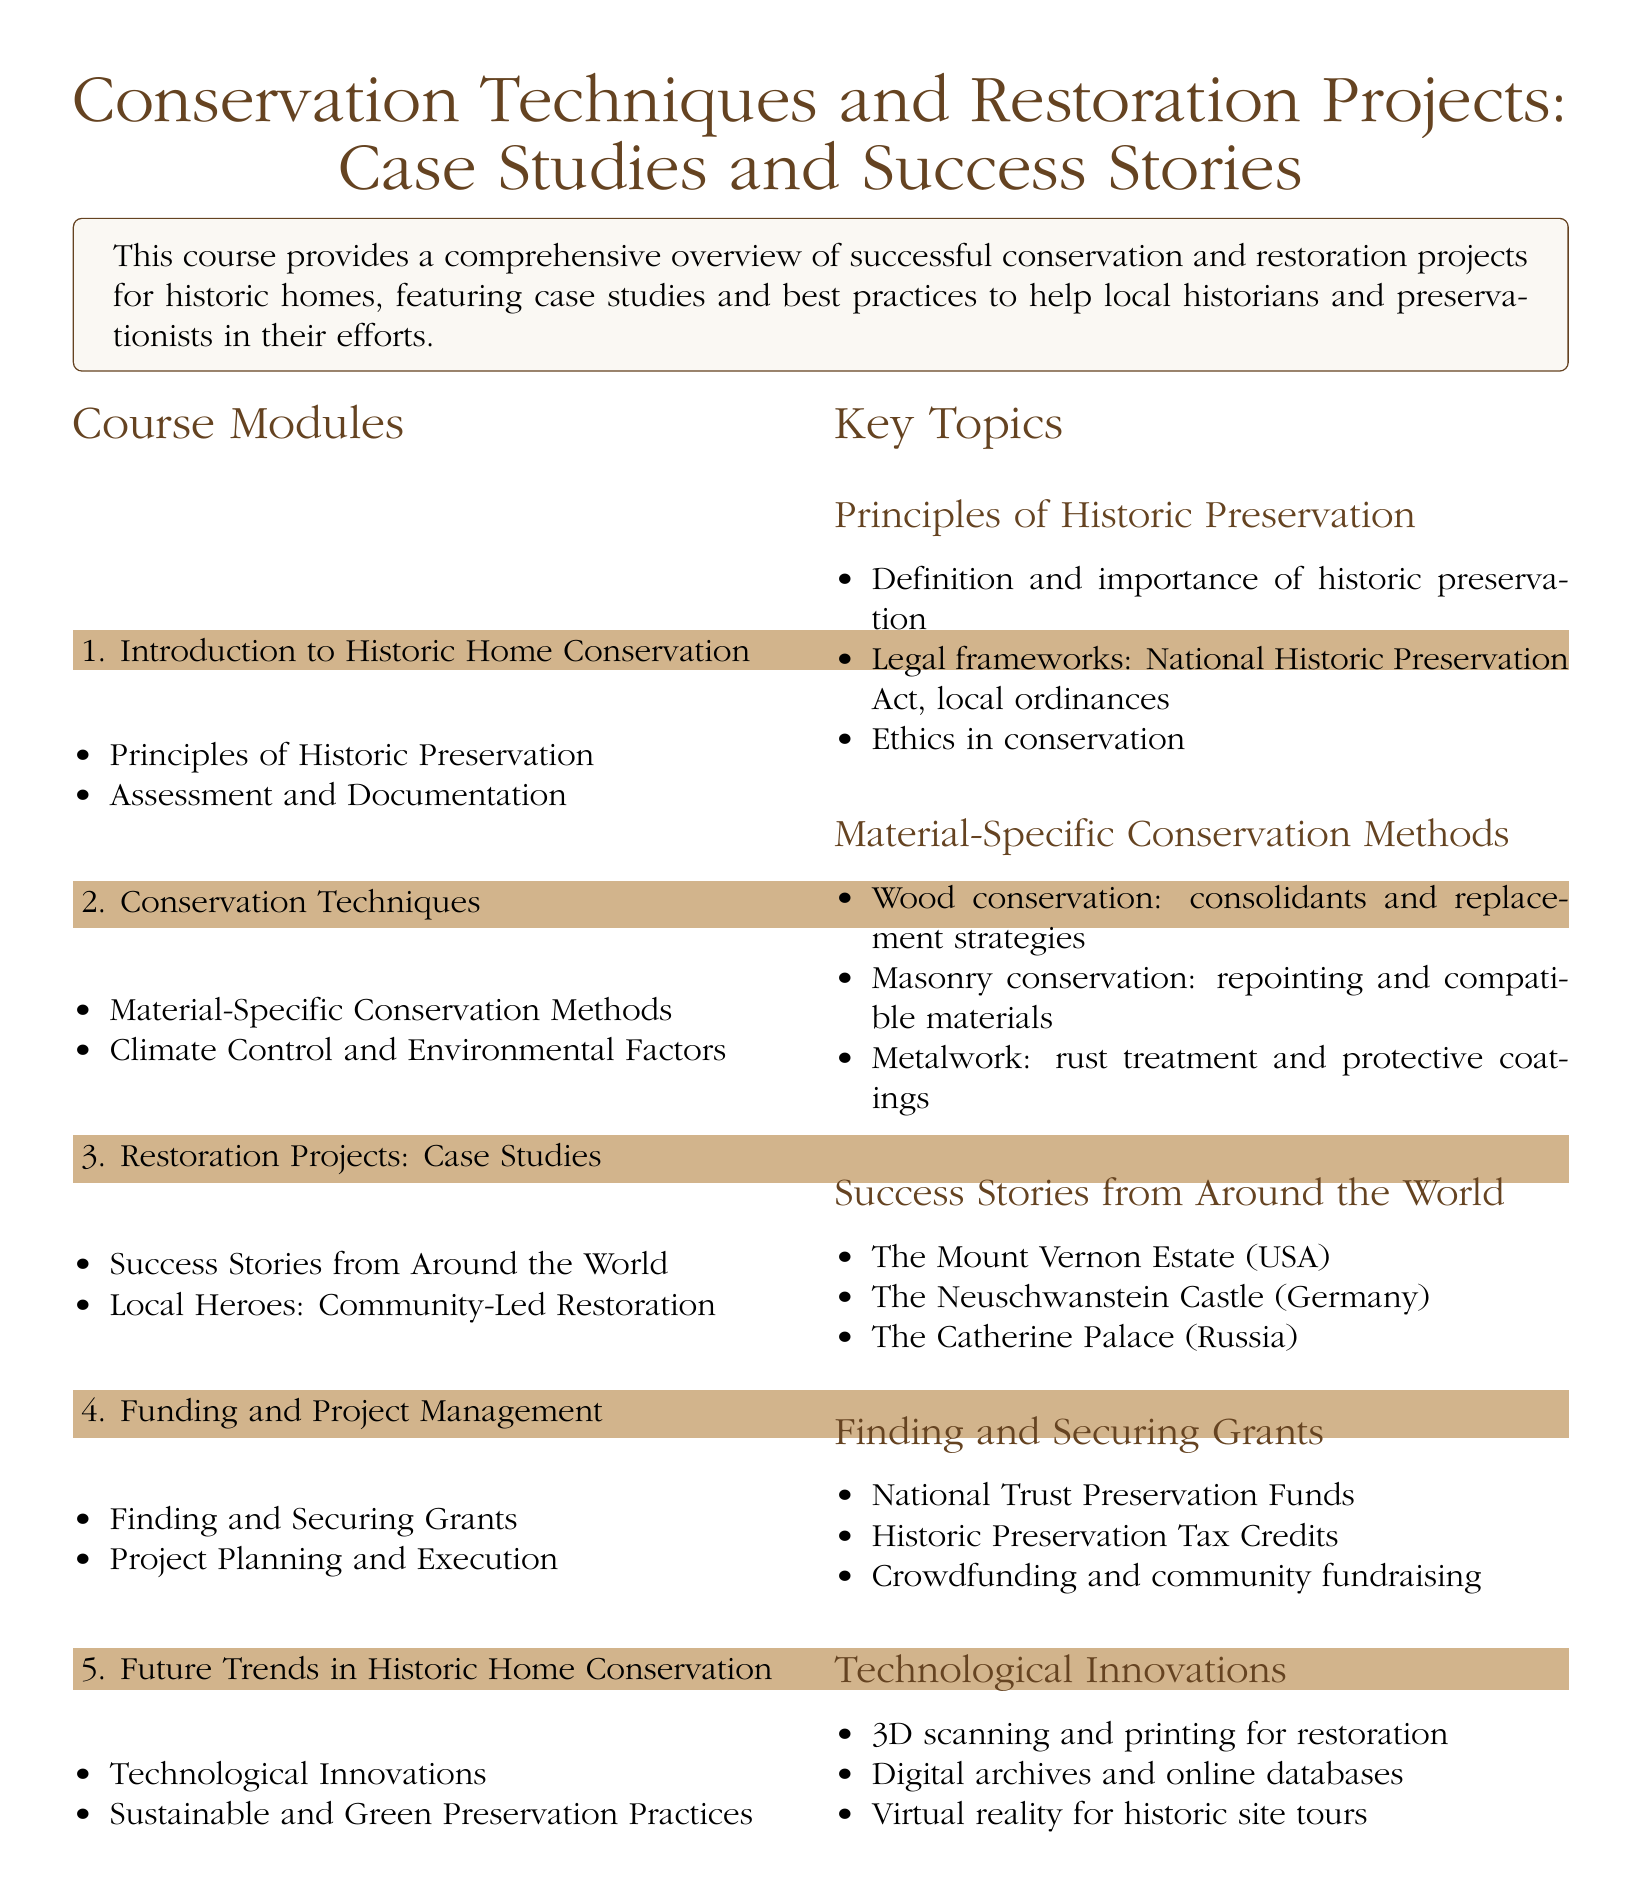What is the title of the document? The title of the document is found prominently at the beginning of the syllabus.
Answer: Conservation Techniques and Restoration Projects: Case Studies and Success Stories How many main modules are there in the course? The number of main modules is listed under the Course Modules section.
Answer: 5 What is included in the key topic "Material-Specific Conservation Methods"? This includes specific conservation strategies for different materials, highlighting methods for preservation.
Answer: Wood conservation, masonry conservation, metalwork Which historic estate is mentioned as a success story in the United States? The specific success story is listed under the Success Stories from Around the World subsection.
Answer: The Mount Vernon Estate What funding sources are suggested for securing grants? The sources of funding for grants are detailed in the Finding and Securing Grants subsection.
Answer: National Trust Preservation Funds, Historic Preservation Tax Credits, crowdfunding What technological innovations are covered in the course? The course discusses various technological advancements that aid in historic preservation.
Answer: 3D scanning and printing, digital archives, virtual reality 